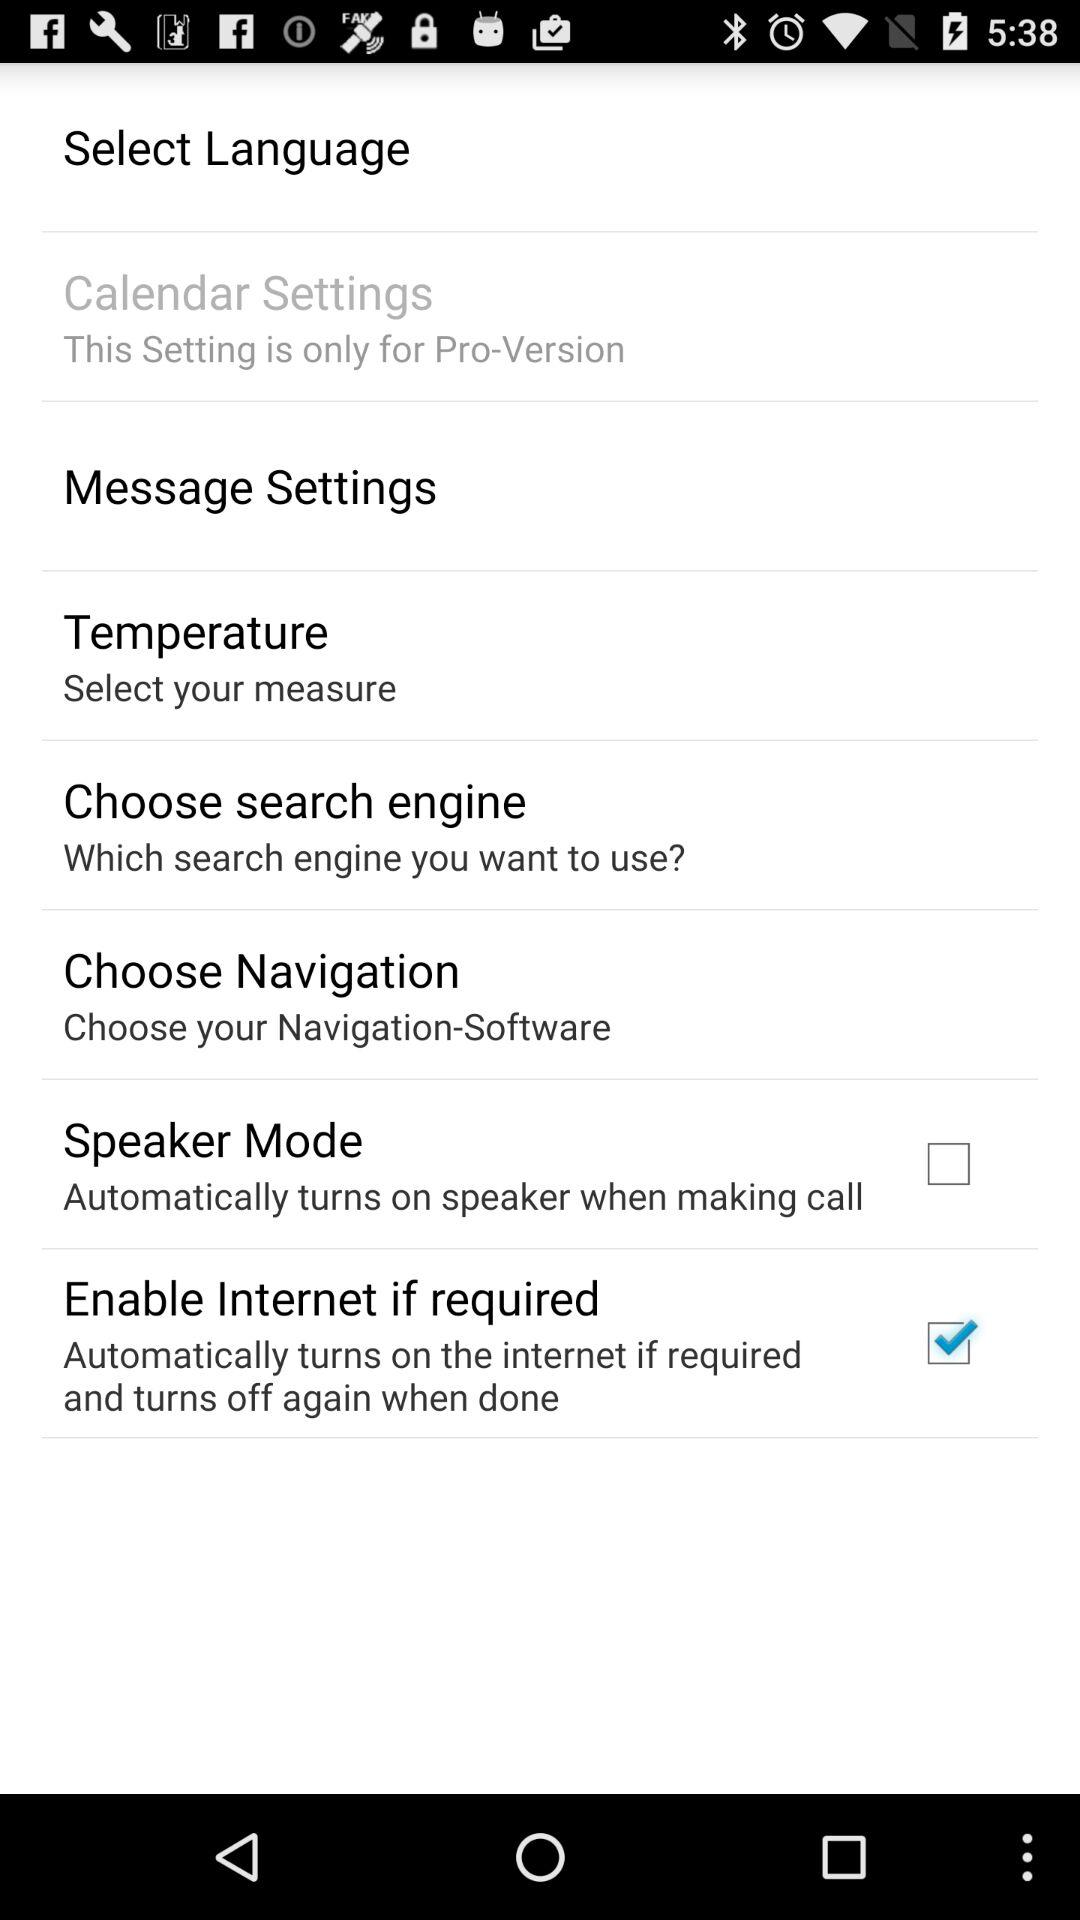What's the selected option? The selected option is "Enable Internet if required". 